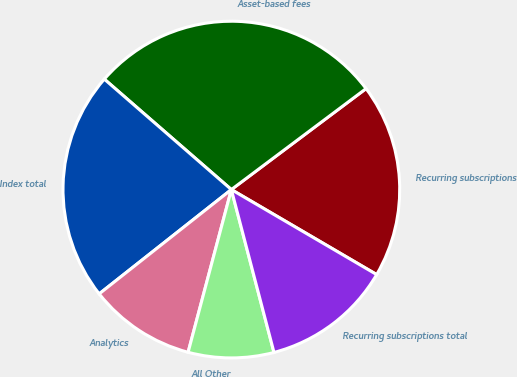Convert chart to OTSL. <chart><loc_0><loc_0><loc_500><loc_500><pie_chart><fcel>Recurring subscriptions<fcel>Asset-based fees<fcel>Index total<fcel>Analytics<fcel>All Other<fcel>Recurring subscriptions total<nl><fcel>18.66%<fcel>28.37%<fcel>22.02%<fcel>10.23%<fcel>8.21%<fcel>12.5%<nl></chart> 